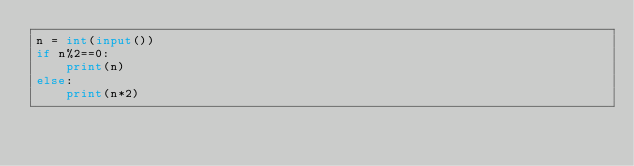Convert code to text. <code><loc_0><loc_0><loc_500><loc_500><_Python_>n = int(input())
if n%2==0:
    print(n)
else:
    print(n*2)





</code> 